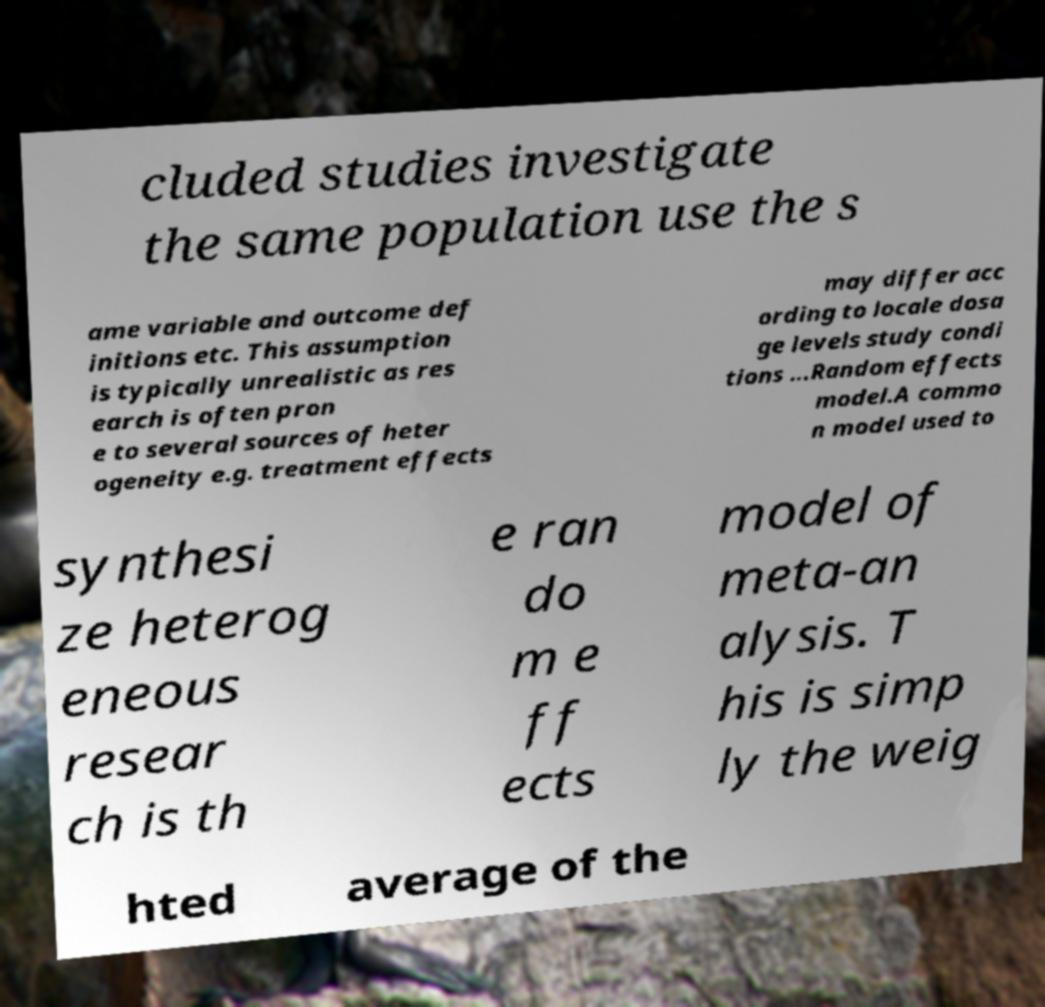Can you accurately transcribe the text from the provided image for me? cluded studies investigate the same population use the s ame variable and outcome def initions etc. This assumption is typically unrealistic as res earch is often pron e to several sources of heter ogeneity e.g. treatment effects may differ acc ording to locale dosa ge levels study condi tions ...Random effects model.A commo n model used to synthesi ze heterog eneous resear ch is th e ran do m e ff ects model of meta-an alysis. T his is simp ly the weig hted average of the 